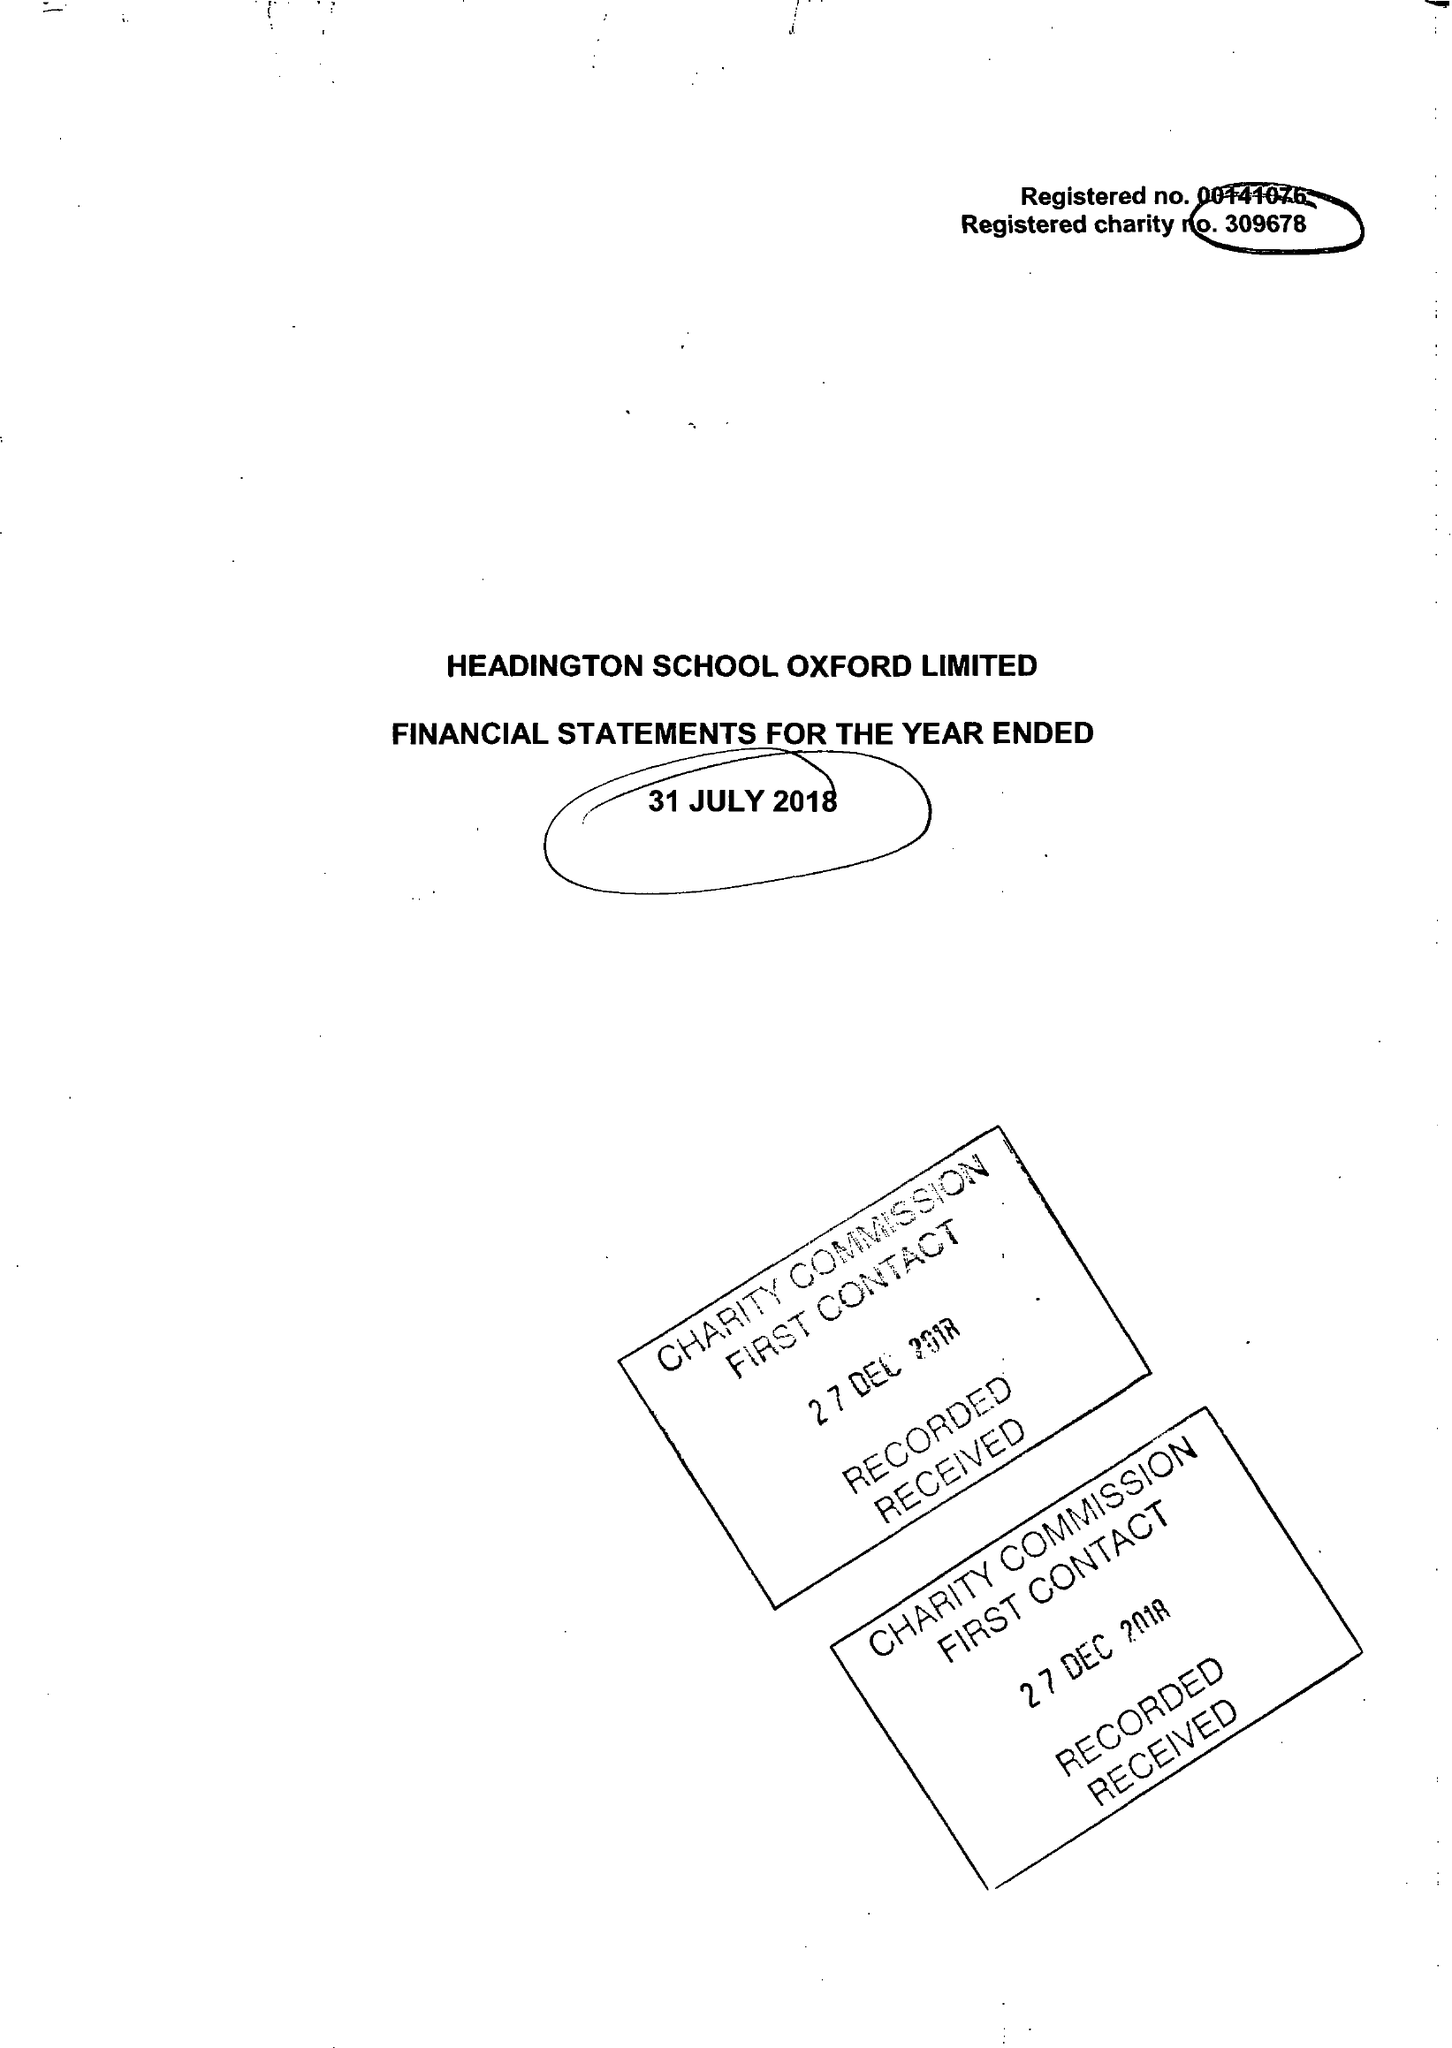What is the value for the address__street_line?
Answer the question using a single word or phrase. HEADINGTON ROAD 